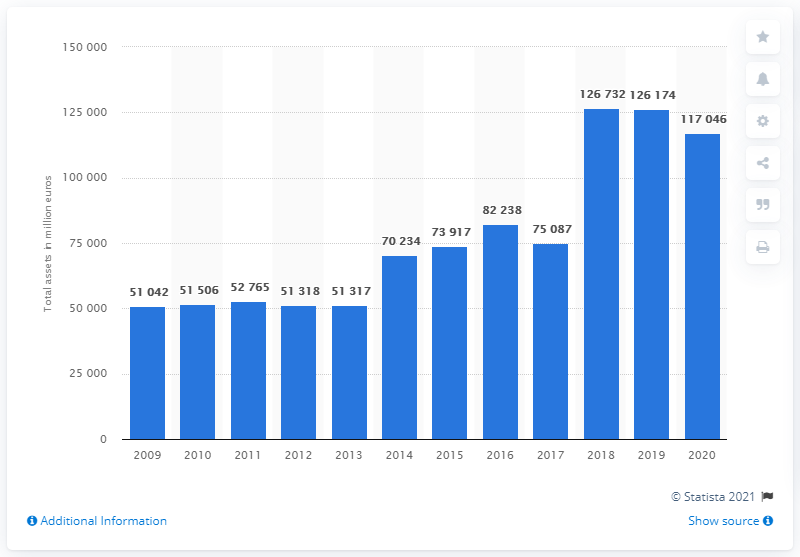List a handful of essential elements in this visual. The total assets of Bayer Group in 2020 were 117,046. 